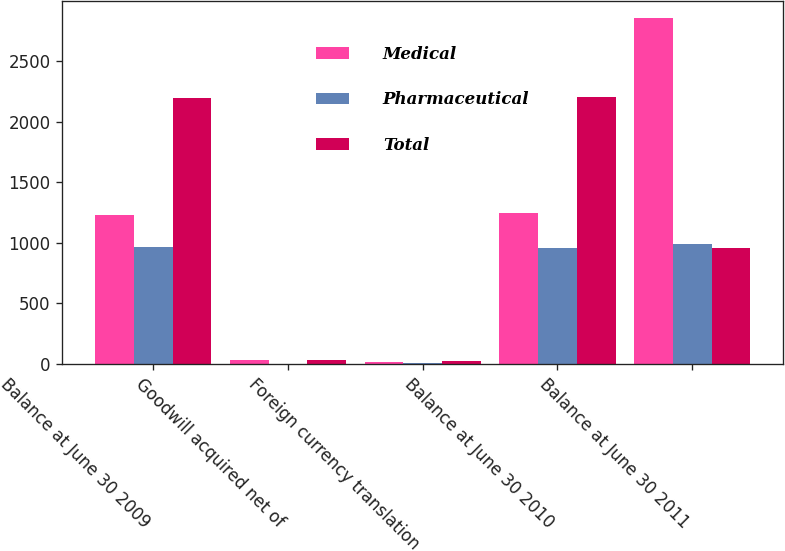Convert chart. <chart><loc_0><loc_0><loc_500><loc_500><stacked_bar_chart><ecel><fcel>Balance at June 30 2009<fcel>Goodwill acquired net of<fcel>Foreign currency translation<fcel>Balance at June 30 2010<fcel>Balance at June 30 2011<nl><fcel>Medical<fcel>1232.8<fcel>33.3<fcel>17.7<fcel>1248.4<fcel>2852.7<nl><fcel>Pharmaceutical<fcel>963.7<fcel>0<fcel>6.7<fcel>957<fcel>992.9<nl><fcel>Total<fcel>2196.5<fcel>33.3<fcel>24.4<fcel>2205.4<fcel>960.35<nl></chart> 